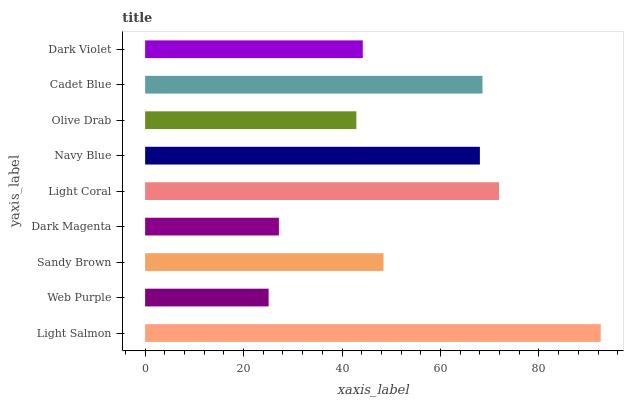Is Web Purple the minimum?
Answer yes or no. Yes. Is Light Salmon the maximum?
Answer yes or no. Yes. Is Sandy Brown the minimum?
Answer yes or no. No. Is Sandy Brown the maximum?
Answer yes or no. No. Is Sandy Brown greater than Web Purple?
Answer yes or no. Yes. Is Web Purple less than Sandy Brown?
Answer yes or no. Yes. Is Web Purple greater than Sandy Brown?
Answer yes or no. No. Is Sandy Brown less than Web Purple?
Answer yes or no. No. Is Sandy Brown the high median?
Answer yes or no. Yes. Is Sandy Brown the low median?
Answer yes or no. Yes. Is Dark Magenta the high median?
Answer yes or no. No. Is Light Coral the low median?
Answer yes or no. No. 